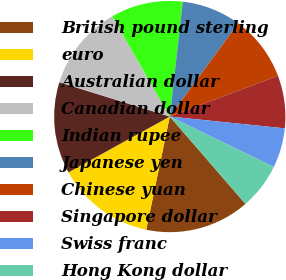<chart> <loc_0><loc_0><loc_500><loc_500><pie_chart><fcel>British pound sterling<fcel>euro<fcel>Australian dollar<fcel>Canadian dollar<fcel>Indian rupee<fcel>Japanese yen<fcel>Chinese yuan<fcel>Singapore dollar<fcel>Swiss franc<fcel>Hong Kong dollar<nl><fcel>14.63%<fcel>13.72%<fcel>12.81%<fcel>11.91%<fcel>10.09%<fcel>8.28%<fcel>9.18%<fcel>7.37%<fcel>5.55%<fcel>6.46%<nl></chart> 